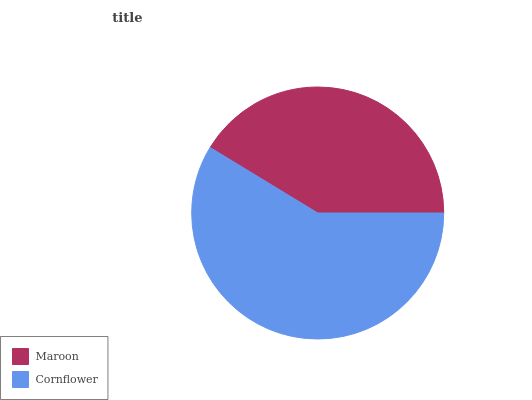Is Maroon the minimum?
Answer yes or no. Yes. Is Cornflower the maximum?
Answer yes or no. Yes. Is Cornflower the minimum?
Answer yes or no. No. Is Cornflower greater than Maroon?
Answer yes or no. Yes. Is Maroon less than Cornflower?
Answer yes or no. Yes. Is Maroon greater than Cornflower?
Answer yes or no. No. Is Cornflower less than Maroon?
Answer yes or no. No. Is Cornflower the high median?
Answer yes or no. Yes. Is Maroon the low median?
Answer yes or no. Yes. Is Maroon the high median?
Answer yes or no. No. Is Cornflower the low median?
Answer yes or no. No. 